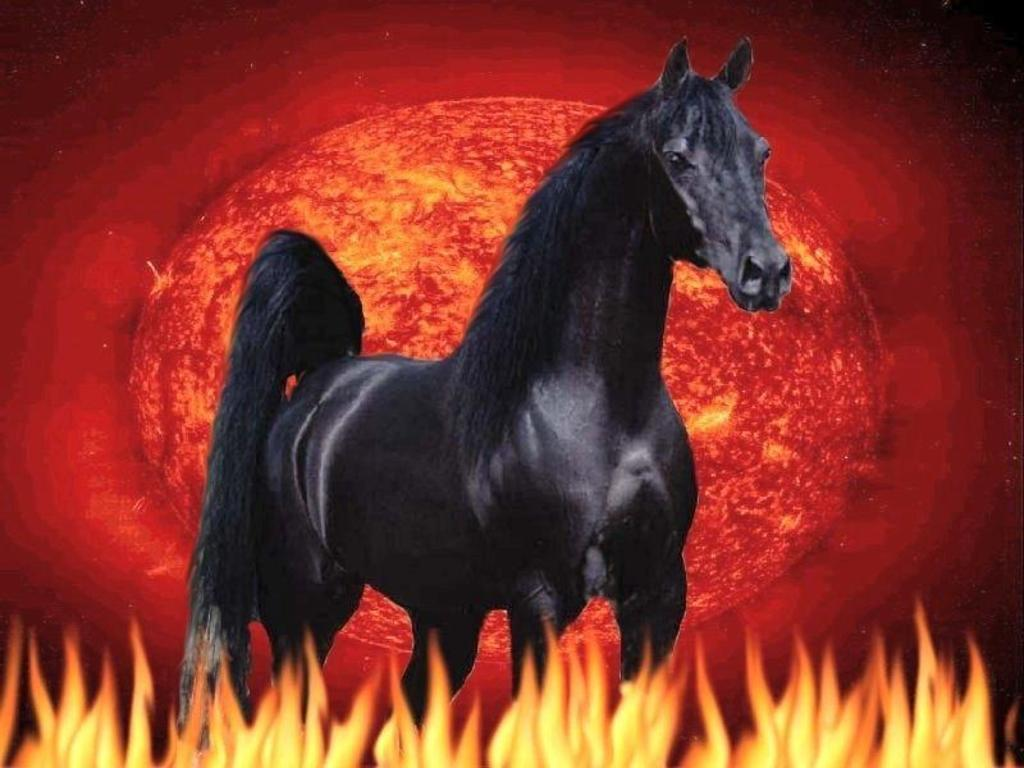What type of image is being described? The image is animated. What animal can be seen in the image? There is a black color horse in the image. What is the other prominent element in the image? There is fire in the image. What color is the background of the image? The background of the image is red. Is there a window visible in the image? There is no mention of a window in the provided facts, so we cannot determine if there is one in the image. --- Facts: 1. There is a person sitting on a chair in the image. 2. The person is holding a book. 3. The book has a blue cover. 4. The chair is made of wood. 5. There is a table next to the chair. Absurd Topics: ocean, parrot, bicycle Conversation: What is the person in the image doing? The person is sitting on a chair in the image. What is the person holding while sitting on the chair? The person is holding a book. What color is the book's cover? The book has a blue cover. What material is the chair made of? The chair is made of wood. What is located next to the chair? There is a table next to the chair. Reasoning: Let's think step by step in order to produce the conversation. We start by identifying the main subject in the image, which is the person sitting on a chair. Then, we describe what the person is holding, which is a book. Next, we mention the color of the book's cover, which is blue. After that, we describe the material of the chair, which is wood. Finally, we mention the presence of a table next to the chair. Absurd Question/Answer: Can you see any ocean or parrot in the image? There is no mention of an ocean or a parrot in the provided facts, so we cannot determine if they are present in the image. 